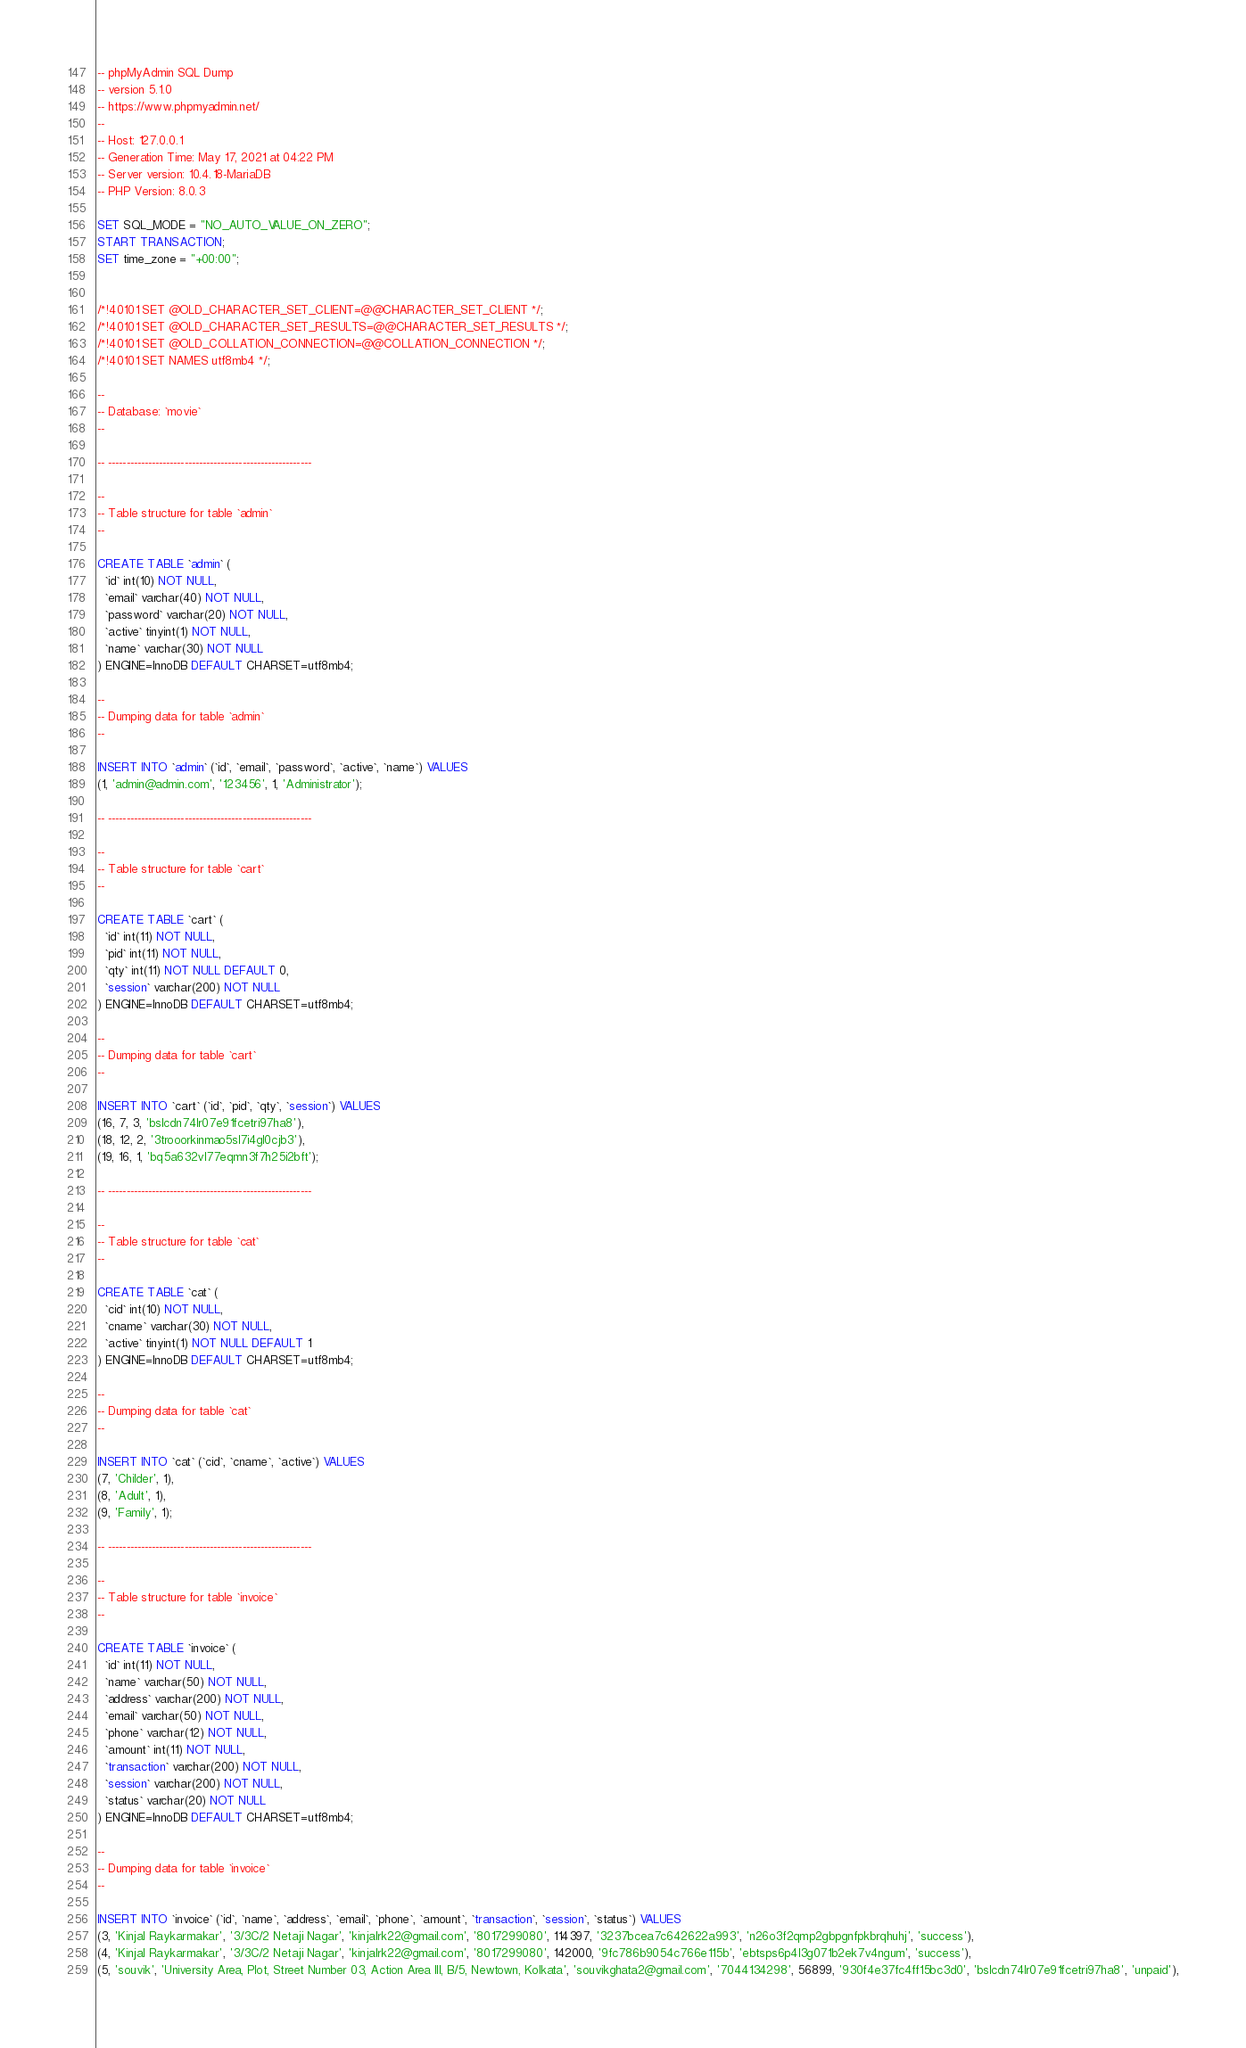Convert code to text. <code><loc_0><loc_0><loc_500><loc_500><_SQL_>-- phpMyAdmin SQL Dump
-- version 5.1.0
-- https://www.phpmyadmin.net/
--
-- Host: 127.0.0.1
-- Generation Time: May 17, 2021 at 04:22 PM
-- Server version: 10.4.18-MariaDB
-- PHP Version: 8.0.3

SET SQL_MODE = "NO_AUTO_VALUE_ON_ZERO";
START TRANSACTION;
SET time_zone = "+00:00";


/*!40101 SET @OLD_CHARACTER_SET_CLIENT=@@CHARACTER_SET_CLIENT */;
/*!40101 SET @OLD_CHARACTER_SET_RESULTS=@@CHARACTER_SET_RESULTS */;
/*!40101 SET @OLD_COLLATION_CONNECTION=@@COLLATION_CONNECTION */;
/*!40101 SET NAMES utf8mb4 */;

--
-- Database: `movie`
--

-- --------------------------------------------------------

--
-- Table structure for table `admin`
--

CREATE TABLE `admin` (
  `id` int(10) NOT NULL,
  `email` varchar(40) NOT NULL,
  `password` varchar(20) NOT NULL,
  `active` tinyint(1) NOT NULL,
  `name` varchar(30) NOT NULL
) ENGINE=InnoDB DEFAULT CHARSET=utf8mb4;

--
-- Dumping data for table `admin`
--

INSERT INTO `admin` (`id`, `email`, `password`, `active`, `name`) VALUES
(1, 'admin@admin.com', '123456', 1, 'Administrator');

-- --------------------------------------------------------

--
-- Table structure for table `cart`
--

CREATE TABLE `cart` (
  `id` int(11) NOT NULL,
  `pid` int(11) NOT NULL,
  `qty` int(11) NOT NULL DEFAULT 0,
  `session` varchar(200) NOT NULL
) ENGINE=InnoDB DEFAULT CHARSET=utf8mb4;

--
-- Dumping data for table `cart`
--

INSERT INTO `cart` (`id`, `pid`, `qty`, `session`) VALUES
(16, 7, 3, 'bslcdn74lr07e91fcetri97ha8'),
(18, 12, 2, '3trooorkinmao5sl7i4gl0cjb3'),
(19, 16, 1, 'bq5a632vl77eqmn3f7h25i2bft');

-- --------------------------------------------------------

--
-- Table structure for table `cat`
--

CREATE TABLE `cat` (
  `cid` int(10) NOT NULL,
  `cname` varchar(30) NOT NULL,
  `active` tinyint(1) NOT NULL DEFAULT 1
) ENGINE=InnoDB DEFAULT CHARSET=utf8mb4;

--
-- Dumping data for table `cat`
--

INSERT INTO `cat` (`cid`, `cname`, `active`) VALUES
(7, 'Childer', 1),
(8, 'Adult', 1),
(9, 'Family', 1);

-- --------------------------------------------------------

--
-- Table structure for table `invoice`
--

CREATE TABLE `invoice` (
  `id` int(11) NOT NULL,
  `name` varchar(50) NOT NULL,
  `address` varchar(200) NOT NULL,
  `email` varchar(50) NOT NULL,
  `phone` varchar(12) NOT NULL,
  `amount` int(11) NOT NULL,
  `transaction` varchar(200) NOT NULL,
  `session` varchar(200) NOT NULL,
  `status` varchar(20) NOT NULL
) ENGINE=InnoDB DEFAULT CHARSET=utf8mb4;

--
-- Dumping data for table `invoice`
--

INSERT INTO `invoice` (`id`, `name`, `address`, `email`, `phone`, `amount`, `transaction`, `session`, `status`) VALUES
(3, 'Kinjal Raykarmakar', '3/3C/2 Netaji Nagar', 'kinjalrk22@gmail.com', '8017299080', 114397, '3237bcea7c642622a993', 'n26o3f2qmp2gbpgnfpkbrqhuhj', 'success'),
(4, 'Kinjal Raykarmakar', '3/3C/2 Netaji Nagar', 'kinjalrk22@gmail.com', '8017299080', 142000, '9fc786b9054c766e115b', 'ebtsps6p4l3g071b2ek7v4ngum', 'success'),
(5, 'souvik', 'University Area, Plot, Street Number 03, Action Area III, B/5, Newtown, Kolkata', 'souvikghata2@gmail.com', '7044134298', 56899, '930f4e37fc4ff15bc3d0', 'bslcdn74lr07e91fcetri97ha8', 'unpaid'),</code> 